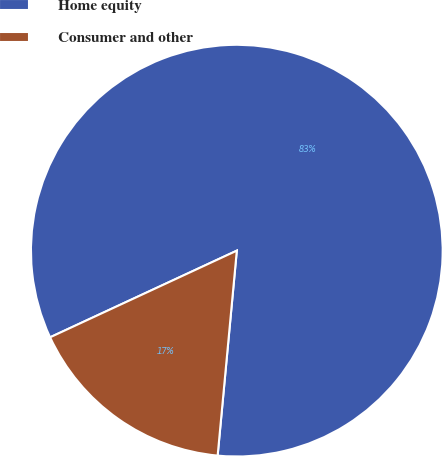<chart> <loc_0><loc_0><loc_500><loc_500><pie_chart><fcel>Home equity<fcel>Consumer and other<nl><fcel>83.4%<fcel>16.6%<nl></chart> 